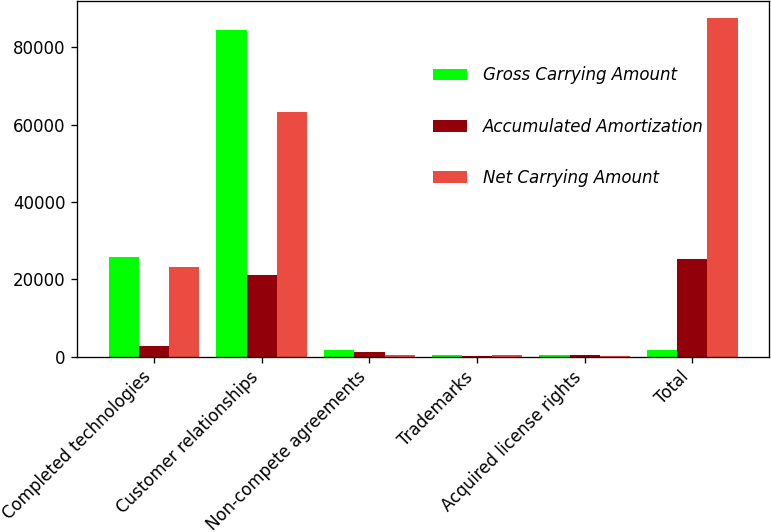Convert chart to OTSL. <chart><loc_0><loc_0><loc_500><loc_500><stacked_bar_chart><ecel><fcel>Completed technologies<fcel>Customer relationships<fcel>Non-compete agreements<fcel>Trademarks<fcel>Acquired license rights<fcel>Total<nl><fcel>Gross Carrying Amount<fcel>25831<fcel>84400<fcel>1600<fcel>500<fcel>490<fcel>1600<nl><fcel>Accumulated Amortization<fcel>2631<fcel>21029<fcel>1108<fcel>109<fcel>444<fcel>25321<nl><fcel>Net Carrying Amount<fcel>23200<fcel>63371<fcel>492<fcel>391<fcel>46<fcel>87500<nl></chart> 